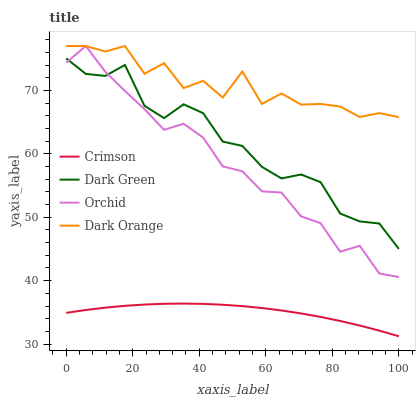Does Crimson have the minimum area under the curve?
Answer yes or no. Yes. Does Dark Orange have the maximum area under the curve?
Answer yes or no. Yes. Does Orchid have the minimum area under the curve?
Answer yes or no. No. Does Orchid have the maximum area under the curve?
Answer yes or no. No. Is Crimson the smoothest?
Answer yes or no. Yes. Is Dark Orange the roughest?
Answer yes or no. Yes. Is Orchid the smoothest?
Answer yes or no. No. Is Orchid the roughest?
Answer yes or no. No. Does Crimson have the lowest value?
Answer yes or no. Yes. Does Orchid have the lowest value?
Answer yes or no. No. Does Orchid have the highest value?
Answer yes or no. Yes. Does Dark Green have the highest value?
Answer yes or no. No. Is Crimson less than Dark Orange?
Answer yes or no. Yes. Is Dark Orange greater than Crimson?
Answer yes or no. Yes. Does Orchid intersect Dark Orange?
Answer yes or no. Yes. Is Orchid less than Dark Orange?
Answer yes or no. No. Is Orchid greater than Dark Orange?
Answer yes or no. No. Does Crimson intersect Dark Orange?
Answer yes or no. No. 